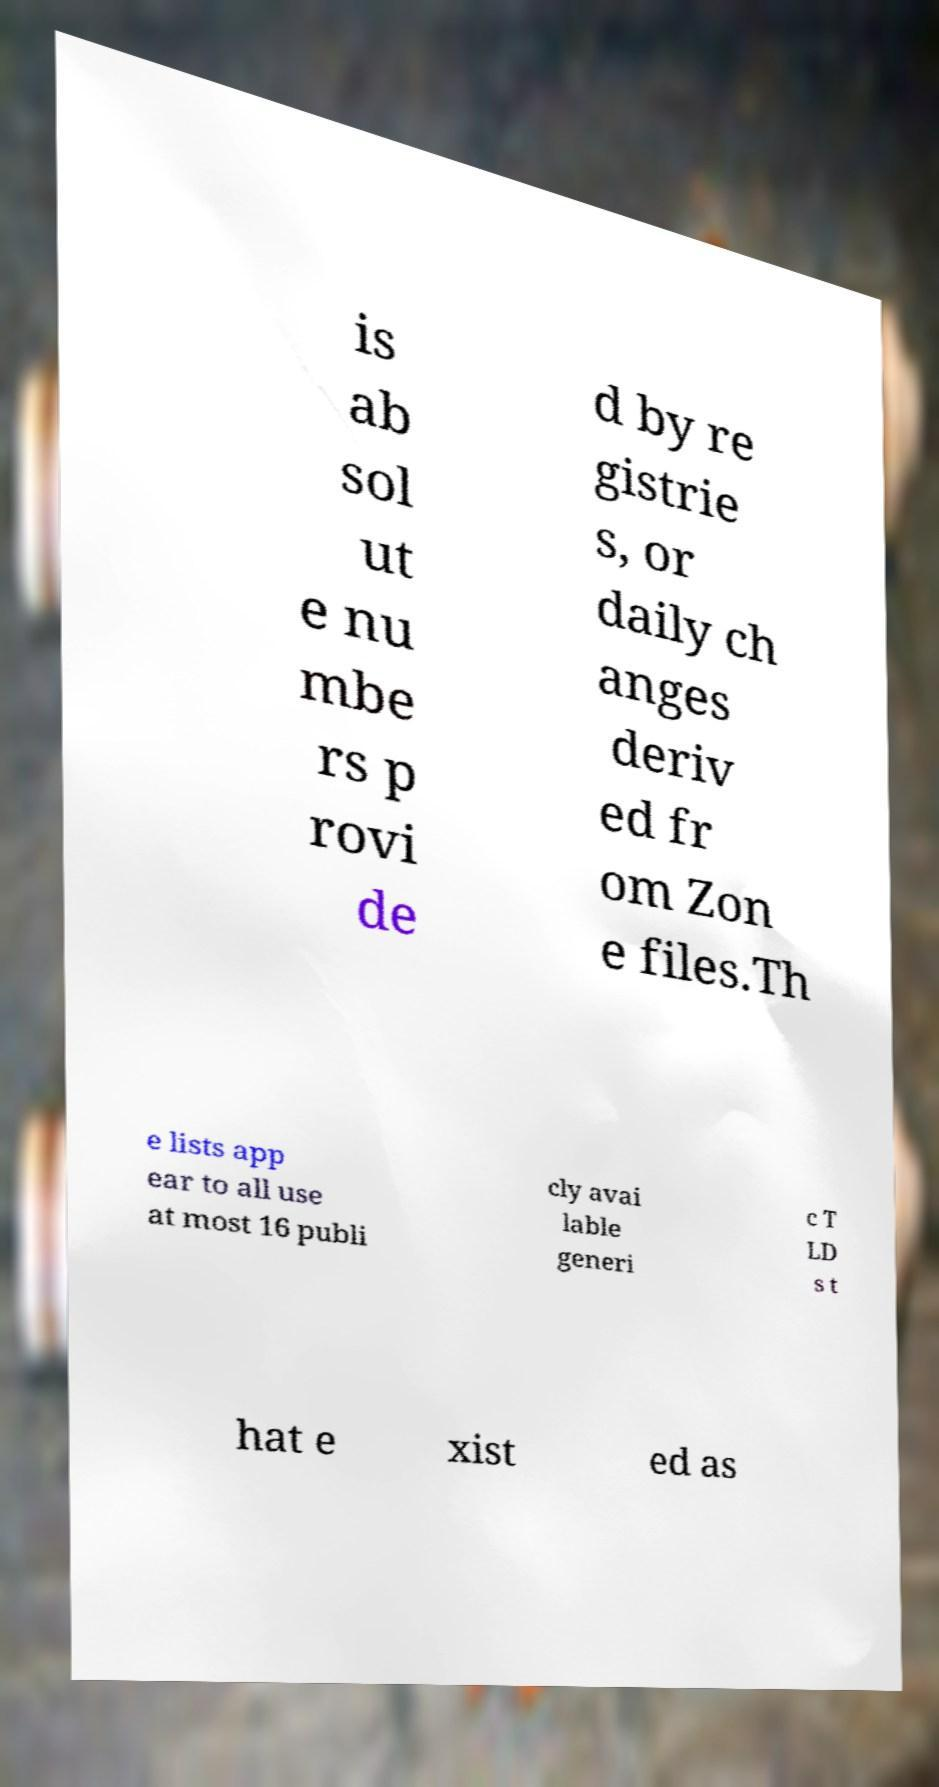What messages or text are displayed in this image? I need them in a readable, typed format. is ab sol ut e nu mbe rs p rovi de d by re gistrie s, or daily ch anges deriv ed fr om Zon e files.Th e lists app ear to all use at most 16 publi cly avai lable generi c T LD s t hat e xist ed as 